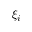<formula> <loc_0><loc_0><loc_500><loc_500>\xi _ { i }</formula> 